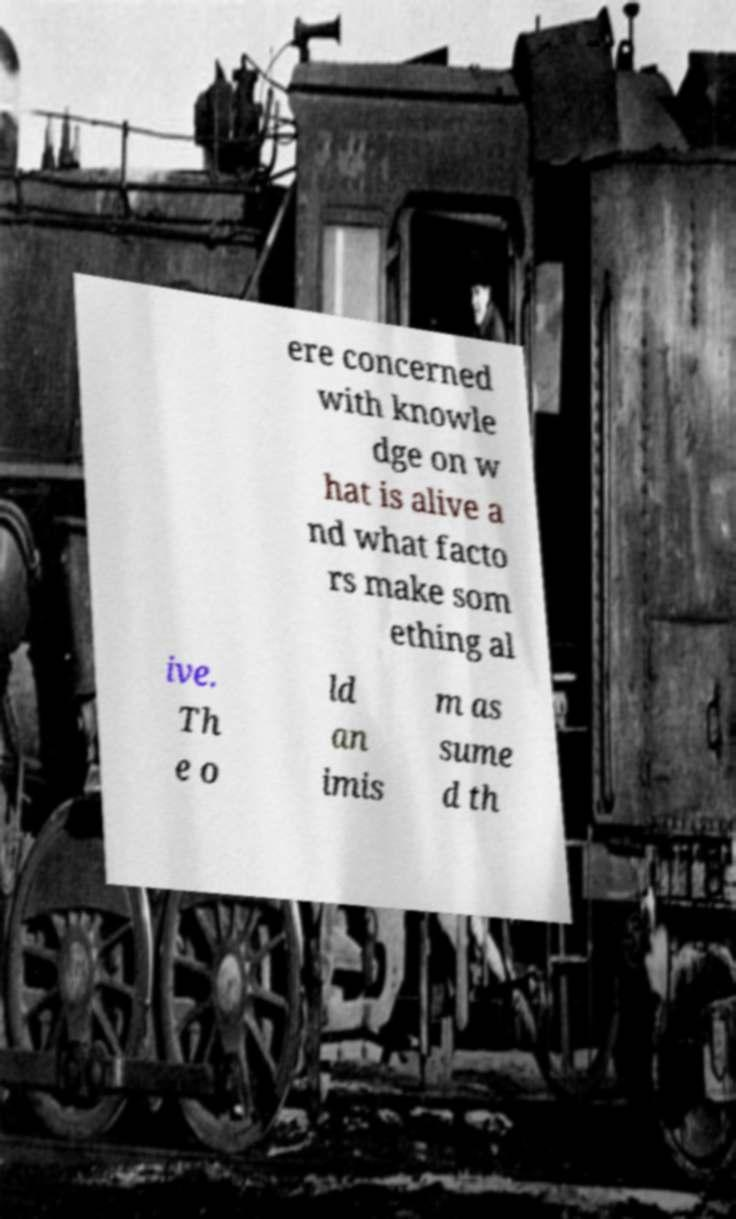For documentation purposes, I need the text within this image transcribed. Could you provide that? ere concerned with knowle dge on w hat is alive a nd what facto rs make som ething al ive. Th e o ld an imis m as sume d th 